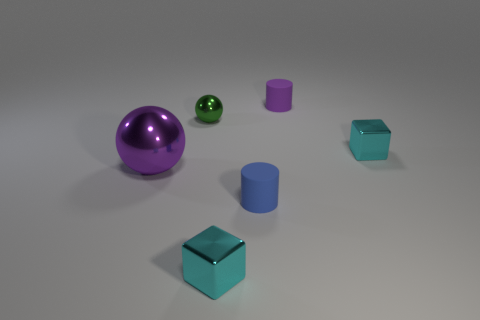Are there any other objects in the picture besides the large purple sphere? Yes, there are several other objects, including a smaller green sphere, two cylinders - one purple and one blue, and two blue cubes. 